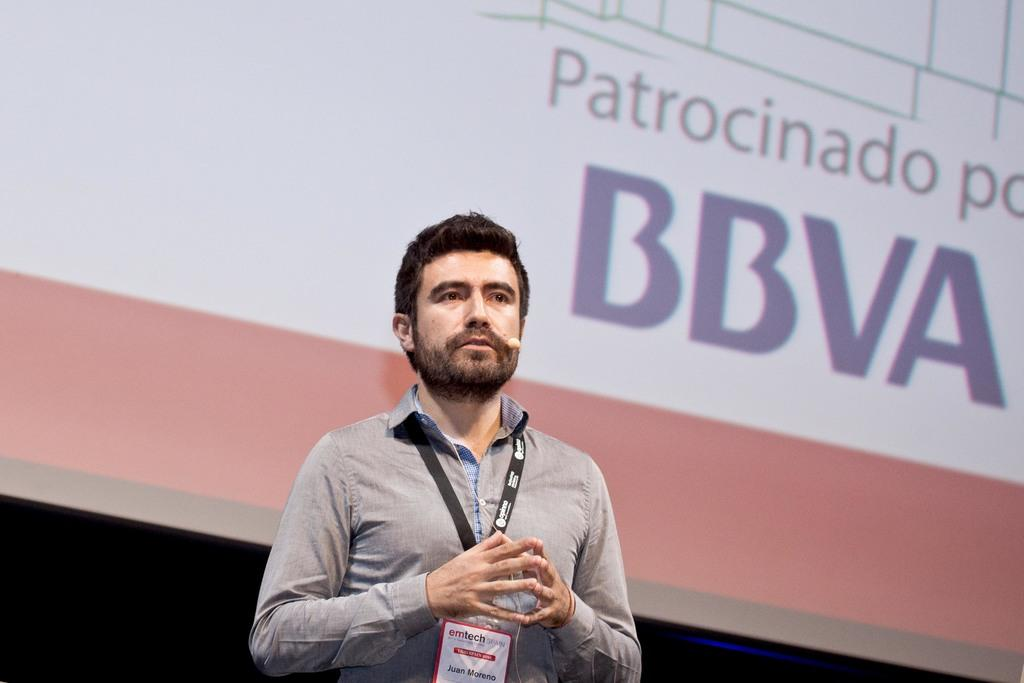Provide a one-sentence caption for the provided image. Juan Moreno giving a presentation for emtech spain. 